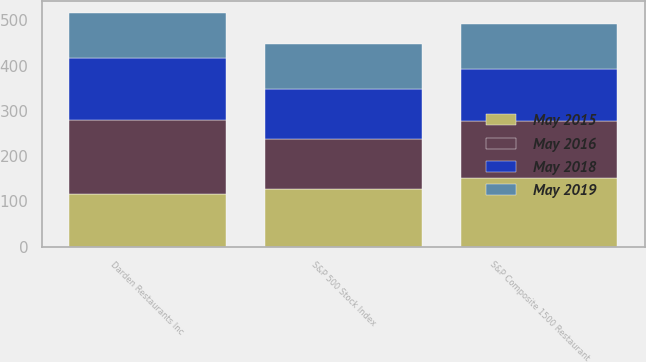Convert chart. <chart><loc_0><loc_0><loc_500><loc_500><stacked_bar_chart><ecel><fcel>Darden Restaurants Inc<fcel>S&P 500 Stock Index<fcel>S&P Composite 1500 Restaurant<nl><fcel>May 2019<fcel>100<fcel>100<fcel>100<nl><fcel>May 2018<fcel>137.7<fcel>110.88<fcel>115.96<nl><fcel>May 2016<fcel>163.41<fcel>110.45<fcel>125.39<nl><fcel>May 2015<fcel>115.96<fcel>127.11<fcel>151.37<nl></chart> 